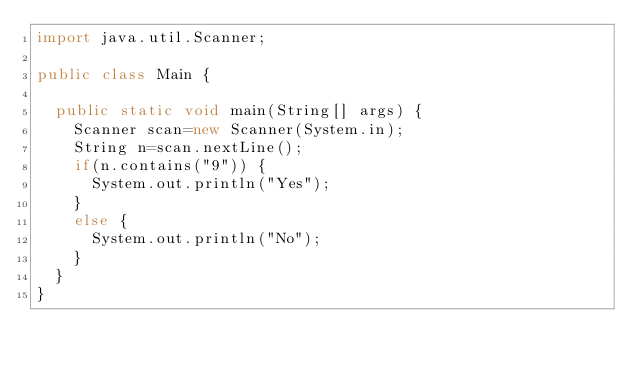Convert code to text. <code><loc_0><loc_0><loc_500><loc_500><_Java_>import java.util.Scanner;

public class Main {

	public static void main(String[] args) {
		Scanner scan=new Scanner(System.in);
		String n=scan.nextLine();
		if(n.contains("9")) {
			System.out.println("Yes");
		}
		else {
			System.out.println("No");
		}
	}
}</code> 